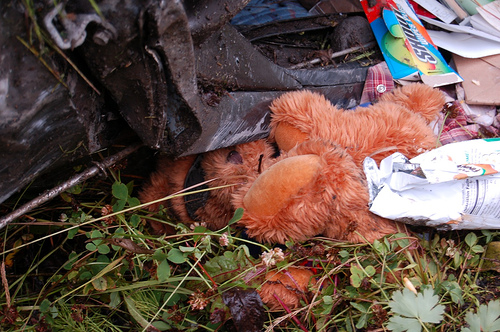<image>
Can you confirm if the bear is under the sunglasses? Yes. The bear is positioned underneath the sunglasses, with the sunglasses above it in the vertical space. 